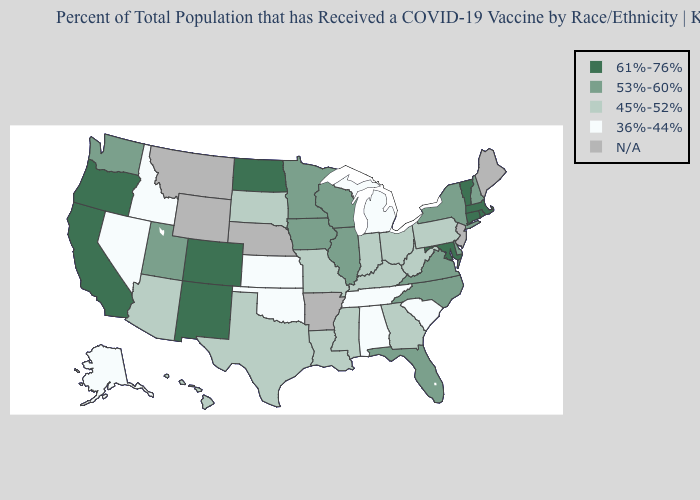Is the legend a continuous bar?
Give a very brief answer. No. What is the highest value in states that border Alabama?
Write a very short answer. 53%-60%. Which states have the highest value in the USA?
Short answer required. California, Colorado, Connecticut, Maryland, Massachusetts, New Mexico, North Dakota, Oregon, Rhode Island, Vermont. Which states have the lowest value in the Northeast?
Give a very brief answer. Pennsylvania. Does the first symbol in the legend represent the smallest category?
Write a very short answer. No. Among the states that border Connecticut , does New York have the lowest value?
Be succinct. Yes. What is the value of South Dakota?
Write a very short answer. 45%-52%. Name the states that have a value in the range 36%-44%?
Give a very brief answer. Alabama, Alaska, Idaho, Kansas, Michigan, Nevada, Oklahoma, South Carolina, Tennessee. What is the highest value in states that border South Dakota?
Keep it brief. 61%-76%. Which states have the lowest value in the South?
Short answer required. Alabama, Oklahoma, South Carolina, Tennessee. What is the lowest value in states that border West Virginia?
Short answer required. 45%-52%. Which states have the lowest value in the USA?
Quick response, please. Alabama, Alaska, Idaho, Kansas, Michigan, Nevada, Oklahoma, South Carolina, Tennessee. What is the lowest value in the USA?
Write a very short answer. 36%-44%. 